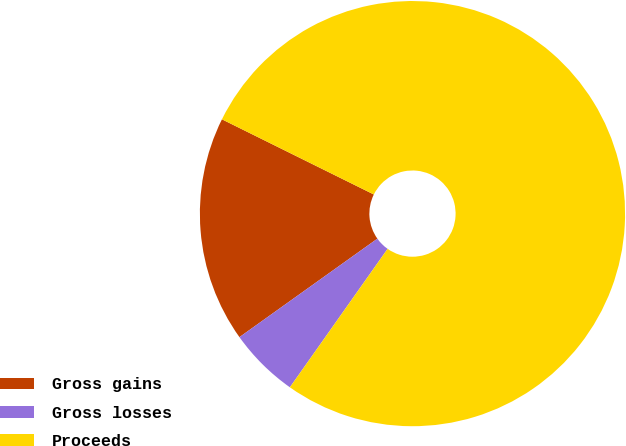<chart> <loc_0><loc_0><loc_500><loc_500><pie_chart><fcel>Gross gains<fcel>Gross losses<fcel>Proceeds<nl><fcel>17.18%<fcel>5.35%<fcel>77.46%<nl></chart> 